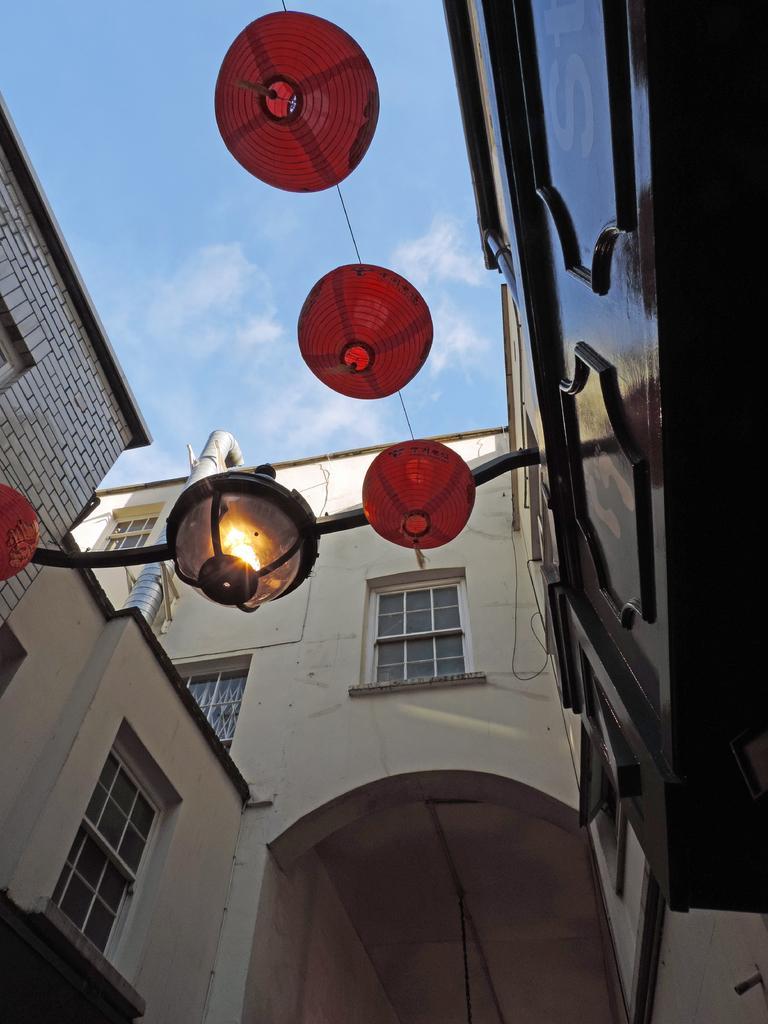Describe this image in one or two sentences. In this image there are some buildings and in the center there are some lights, and at the top there is sky. 